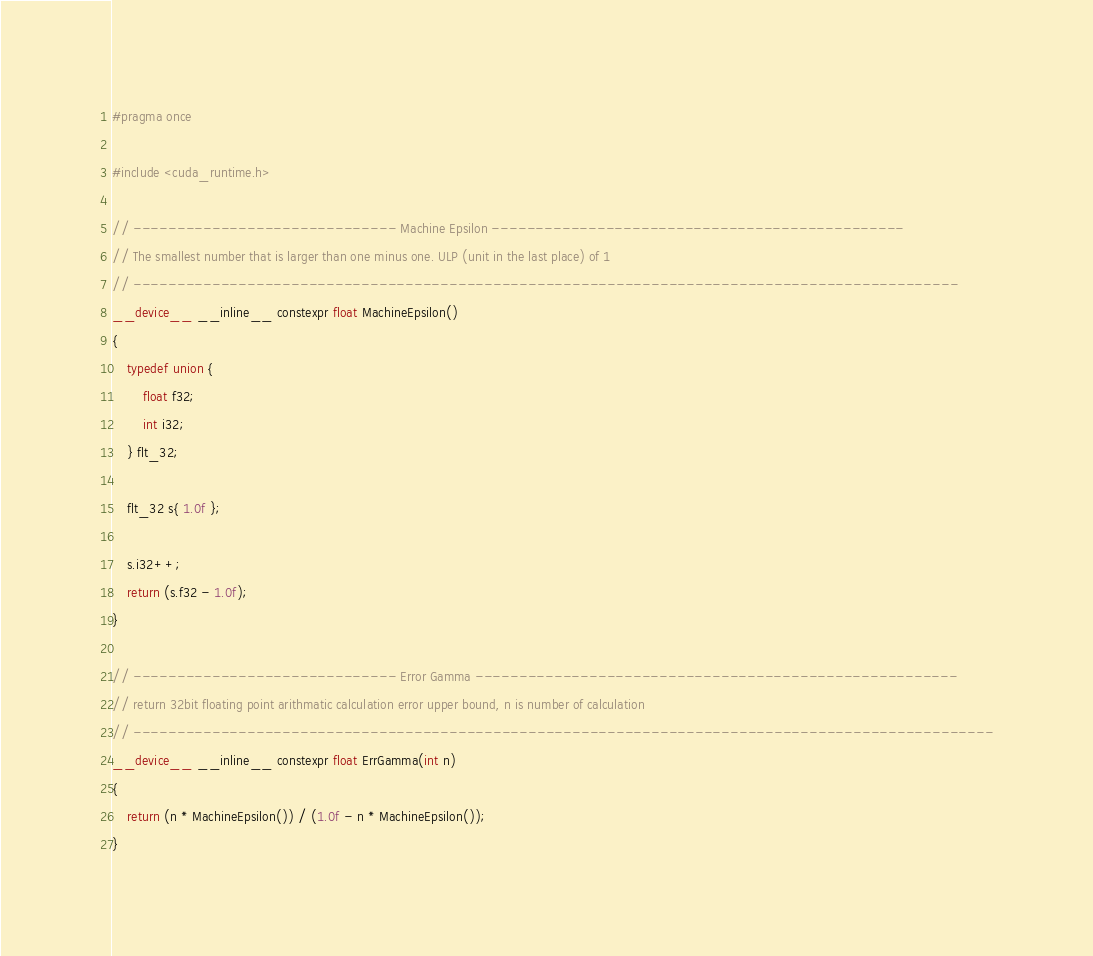<code> <loc_0><loc_0><loc_500><loc_500><_Cuda_>#pragma once

#include <cuda_runtime.h>

// ------------------------------ Machine Epsilon -----------------------------------------------
// The smallest number that is larger than one minus one. ULP (unit in the last place) of 1
// ----------------------------------------------------------------------------------------------
__device__ __inline__ constexpr float MachineEpsilon()
{
	typedef union {
		float f32;
		int i32;
	} flt_32;

	flt_32 s{ 1.0f };

	s.i32++;
	return (s.f32 - 1.0f);
}

// ------------------------------ Error Gamma -------------------------------------------------------
// return 32bit floating point arithmatic calculation error upper bound, n is number of calculation
// --------------------------------------------------------------------------------------------------
__device__ __inline__ constexpr float ErrGamma(int n)
{
	return (n * MachineEpsilon()) / (1.0f - n * MachineEpsilon());
}</code> 